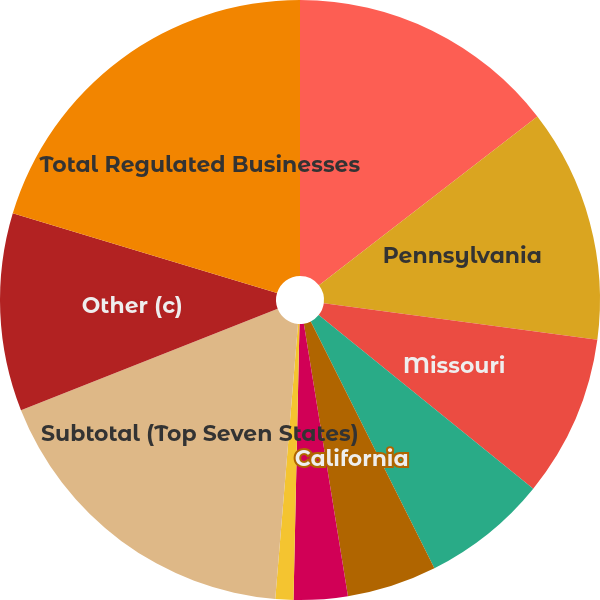Convert chart to OTSL. <chart><loc_0><loc_0><loc_500><loc_500><pie_chart><fcel>New Jersey<fcel>Pennsylvania<fcel>Missouri<fcel>Illinois (a)<fcel>California<fcel>Indiana<fcel>West Virginia (b)<fcel>Subtotal (Top Seven States)<fcel>Other (c)<fcel>Total Regulated Businesses<nl><fcel>14.53%<fcel>12.59%<fcel>8.71%<fcel>6.78%<fcel>4.84%<fcel>2.9%<fcel>0.97%<fcel>17.7%<fcel>10.65%<fcel>20.34%<nl></chart> 